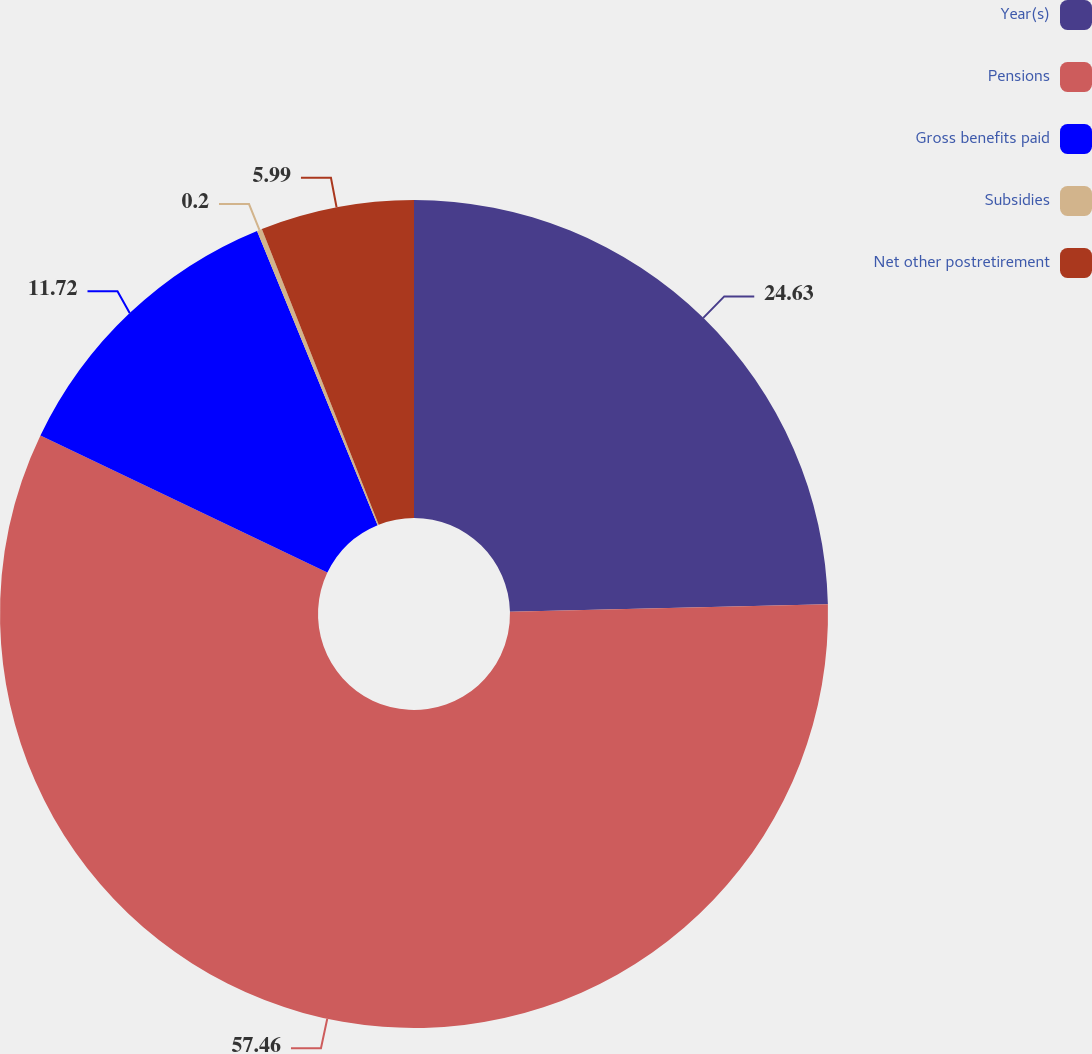Convert chart. <chart><loc_0><loc_0><loc_500><loc_500><pie_chart><fcel>Year(s)<fcel>Pensions<fcel>Gross benefits paid<fcel>Subsidies<fcel>Net other postretirement<nl><fcel>24.63%<fcel>57.47%<fcel>11.72%<fcel>0.2%<fcel>5.99%<nl></chart> 